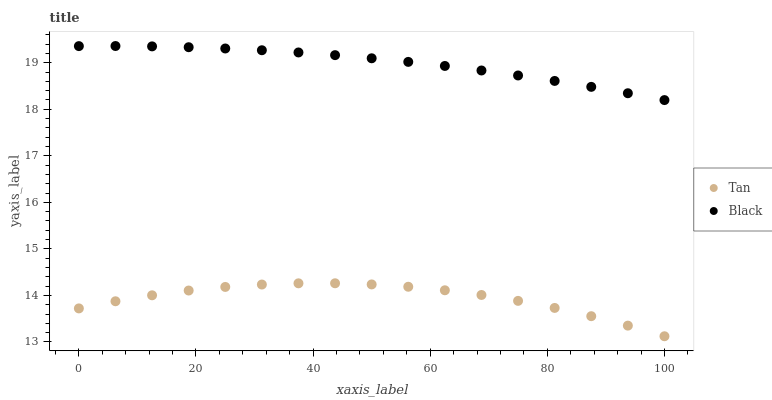Does Tan have the minimum area under the curve?
Answer yes or no. Yes. Does Black have the maximum area under the curve?
Answer yes or no. Yes. Does Black have the minimum area under the curve?
Answer yes or no. No. Is Black the smoothest?
Answer yes or no. Yes. Is Tan the roughest?
Answer yes or no. Yes. Is Black the roughest?
Answer yes or no. No. Does Tan have the lowest value?
Answer yes or no. Yes. Does Black have the lowest value?
Answer yes or no. No. Does Black have the highest value?
Answer yes or no. Yes. Is Tan less than Black?
Answer yes or no. Yes. Is Black greater than Tan?
Answer yes or no. Yes. Does Tan intersect Black?
Answer yes or no. No. 